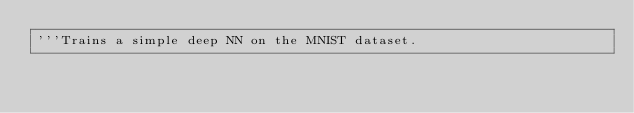Convert code to text. <code><loc_0><loc_0><loc_500><loc_500><_Python_>'''Trains a simple deep NN on the MNIST dataset.
</code> 